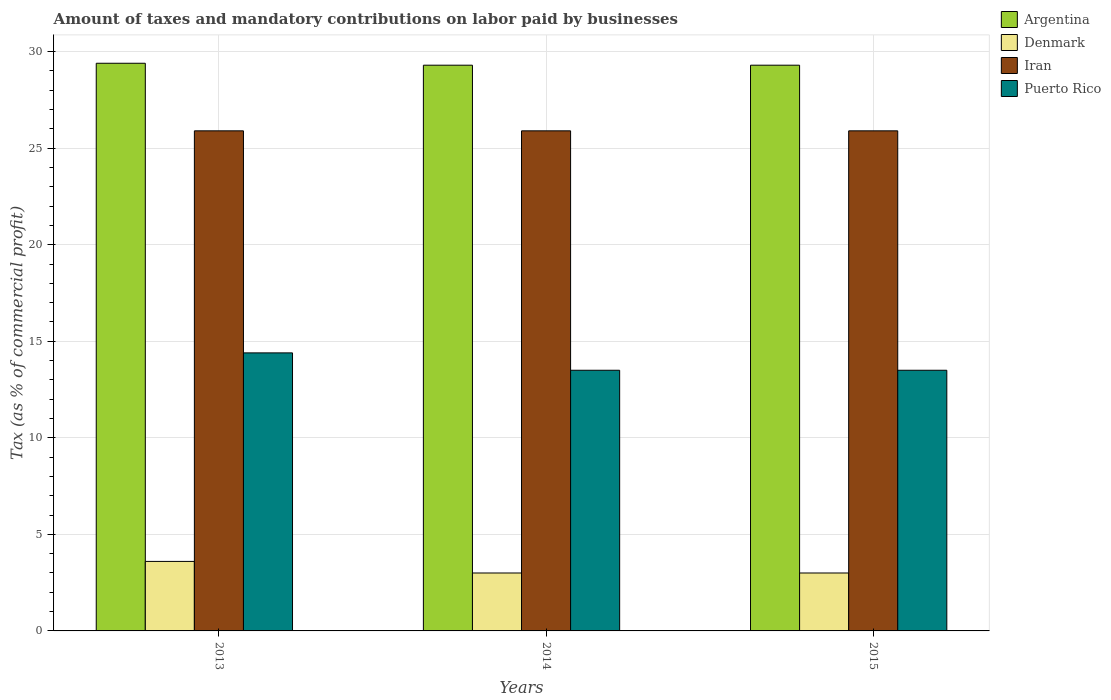How many bars are there on the 3rd tick from the left?
Keep it short and to the point. 4. How many bars are there on the 1st tick from the right?
Give a very brief answer. 4. What is the label of the 3rd group of bars from the left?
Offer a terse response. 2015. In how many cases, is the number of bars for a given year not equal to the number of legend labels?
Provide a short and direct response. 0. Across all years, what is the maximum percentage of taxes paid by businesses in Argentina?
Your answer should be very brief. 29.4. In which year was the percentage of taxes paid by businesses in Argentina maximum?
Your answer should be compact. 2013. In which year was the percentage of taxes paid by businesses in Puerto Rico minimum?
Your response must be concise. 2014. What is the total percentage of taxes paid by businesses in Argentina in the graph?
Provide a succinct answer. 88. What is the difference between the percentage of taxes paid by businesses in Iran in 2014 and that in 2015?
Your answer should be compact. 0. What is the difference between the percentage of taxes paid by businesses in Argentina in 2015 and the percentage of taxes paid by businesses in Puerto Rico in 2014?
Keep it short and to the point. 15.8. What is the average percentage of taxes paid by businesses in Puerto Rico per year?
Your answer should be compact. 13.8. In the year 2013, what is the difference between the percentage of taxes paid by businesses in Puerto Rico and percentage of taxes paid by businesses in Argentina?
Your response must be concise. -15. In how many years, is the percentage of taxes paid by businesses in Puerto Rico greater than 5 %?
Offer a very short reply. 3. Is the percentage of taxes paid by businesses in Puerto Rico in 2013 less than that in 2014?
Offer a terse response. No. Is the difference between the percentage of taxes paid by businesses in Puerto Rico in 2014 and 2015 greater than the difference between the percentage of taxes paid by businesses in Argentina in 2014 and 2015?
Provide a short and direct response. No. What is the difference between the highest and the second highest percentage of taxes paid by businesses in Denmark?
Ensure brevity in your answer.  0.6. What is the difference between the highest and the lowest percentage of taxes paid by businesses in Denmark?
Ensure brevity in your answer.  0.6. In how many years, is the percentage of taxes paid by businesses in Argentina greater than the average percentage of taxes paid by businesses in Argentina taken over all years?
Ensure brevity in your answer.  1. Is the sum of the percentage of taxes paid by businesses in Puerto Rico in 2013 and 2015 greater than the maximum percentage of taxes paid by businesses in Denmark across all years?
Your response must be concise. Yes. What does the 4th bar from the left in 2013 represents?
Make the answer very short. Puerto Rico. Is it the case that in every year, the sum of the percentage of taxes paid by businesses in Argentina and percentage of taxes paid by businesses in Puerto Rico is greater than the percentage of taxes paid by businesses in Denmark?
Keep it short and to the point. Yes. Does the graph contain any zero values?
Offer a terse response. No. Where does the legend appear in the graph?
Your response must be concise. Top right. How are the legend labels stacked?
Your answer should be compact. Vertical. What is the title of the graph?
Provide a succinct answer. Amount of taxes and mandatory contributions on labor paid by businesses. Does "Cameroon" appear as one of the legend labels in the graph?
Your answer should be compact. No. What is the label or title of the X-axis?
Offer a very short reply. Years. What is the label or title of the Y-axis?
Your answer should be compact. Tax (as % of commercial profit). What is the Tax (as % of commercial profit) in Argentina in 2013?
Offer a very short reply. 29.4. What is the Tax (as % of commercial profit) of Iran in 2013?
Offer a very short reply. 25.9. What is the Tax (as % of commercial profit) in Puerto Rico in 2013?
Your response must be concise. 14.4. What is the Tax (as % of commercial profit) in Argentina in 2014?
Your answer should be very brief. 29.3. What is the Tax (as % of commercial profit) in Denmark in 2014?
Offer a terse response. 3. What is the Tax (as % of commercial profit) of Iran in 2014?
Your response must be concise. 25.9. What is the Tax (as % of commercial profit) of Argentina in 2015?
Offer a very short reply. 29.3. What is the Tax (as % of commercial profit) in Denmark in 2015?
Make the answer very short. 3. What is the Tax (as % of commercial profit) in Iran in 2015?
Give a very brief answer. 25.9. What is the Tax (as % of commercial profit) of Puerto Rico in 2015?
Offer a very short reply. 13.5. Across all years, what is the maximum Tax (as % of commercial profit) of Argentina?
Ensure brevity in your answer.  29.4. Across all years, what is the maximum Tax (as % of commercial profit) of Denmark?
Your response must be concise. 3.6. Across all years, what is the maximum Tax (as % of commercial profit) of Iran?
Your answer should be compact. 25.9. Across all years, what is the maximum Tax (as % of commercial profit) in Puerto Rico?
Keep it short and to the point. 14.4. Across all years, what is the minimum Tax (as % of commercial profit) of Argentina?
Ensure brevity in your answer.  29.3. Across all years, what is the minimum Tax (as % of commercial profit) in Iran?
Ensure brevity in your answer.  25.9. Across all years, what is the minimum Tax (as % of commercial profit) of Puerto Rico?
Your answer should be very brief. 13.5. What is the total Tax (as % of commercial profit) of Argentina in the graph?
Your response must be concise. 88. What is the total Tax (as % of commercial profit) of Iran in the graph?
Keep it short and to the point. 77.7. What is the total Tax (as % of commercial profit) of Puerto Rico in the graph?
Your response must be concise. 41.4. What is the difference between the Tax (as % of commercial profit) in Argentina in 2013 and that in 2014?
Your response must be concise. 0.1. What is the difference between the Tax (as % of commercial profit) of Puerto Rico in 2013 and that in 2014?
Ensure brevity in your answer.  0.9. What is the difference between the Tax (as % of commercial profit) of Denmark in 2013 and that in 2015?
Offer a very short reply. 0.6. What is the difference between the Tax (as % of commercial profit) of Puerto Rico in 2014 and that in 2015?
Your response must be concise. 0. What is the difference between the Tax (as % of commercial profit) in Argentina in 2013 and the Tax (as % of commercial profit) in Denmark in 2014?
Provide a short and direct response. 26.4. What is the difference between the Tax (as % of commercial profit) in Denmark in 2013 and the Tax (as % of commercial profit) in Iran in 2014?
Make the answer very short. -22.3. What is the difference between the Tax (as % of commercial profit) of Denmark in 2013 and the Tax (as % of commercial profit) of Puerto Rico in 2014?
Offer a terse response. -9.9. What is the difference between the Tax (as % of commercial profit) of Argentina in 2013 and the Tax (as % of commercial profit) of Denmark in 2015?
Make the answer very short. 26.4. What is the difference between the Tax (as % of commercial profit) of Argentina in 2013 and the Tax (as % of commercial profit) of Iran in 2015?
Your answer should be compact. 3.5. What is the difference between the Tax (as % of commercial profit) of Argentina in 2013 and the Tax (as % of commercial profit) of Puerto Rico in 2015?
Your answer should be very brief. 15.9. What is the difference between the Tax (as % of commercial profit) of Denmark in 2013 and the Tax (as % of commercial profit) of Iran in 2015?
Provide a short and direct response. -22.3. What is the difference between the Tax (as % of commercial profit) of Iran in 2013 and the Tax (as % of commercial profit) of Puerto Rico in 2015?
Provide a succinct answer. 12.4. What is the difference between the Tax (as % of commercial profit) in Argentina in 2014 and the Tax (as % of commercial profit) in Denmark in 2015?
Your answer should be compact. 26.3. What is the difference between the Tax (as % of commercial profit) of Argentina in 2014 and the Tax (as % of commercial profit) of Puerto Rico in 2015?
Provide a succinct answer. 15.8. What is the difference between the Tax (as % of commercial profit) of Denmark in 2014 and the Tax (as % of commercial profit) of Iran in 2015?
Provide a succinct answer. -22.9. What is the average Tax (as % of commercial profit) in Argentina per year?
Make the answer very short. 29.33. What is the average Tax (as % of commercial profit) of Iran per year?
Offer a very short reply. 25.9. What is the average Tax (as % of commercial profit) of Puerto Rico per year?
Provide a succinct answer. 13.8. In the year 2013, what is the difference between the Tax (as % of commercial profit) in Argentina and Tax (as % of commercial profit) in Denmark?
Your answer should be compact. 25.8. In the year 2013, what is the difference between the Tax (as % of commercial profit) in Denmark and Tax (as % of commercial profit) in Iran?
Give a very brief answer. -22.3. In the year 2014, what is the difference between the Tax (as % of commercial profit) in Argentina and Tax (as % of commercial profit) in Denmark?
Provide a short and direct response. 26.3. In the year 2014, what is the difference between the Tax (as % of commercial profit) in Denmark and Tax (as % of commercial profit) in Iran?
Provide a succinct answer. -22.9. In the year 2015, what is the difference between the Tax (as % of commercial profit) of Argentina and Tax (as % of commercial profit) of Denmark?
Your answer should be very brief. 26.3. In the year 2015, what is the difference between the Tax (as % of commercial profit) of Argentina and Tax (as % of commercial profit) of Iran?
Keep it short and to the point. 3.4. In the year 2015, what is the difference between the Tax (as % of commercial profit) in Denmark and Tax (as % of commercial profit) in Iran?
Your answer should be very brief. -22.9. In the year 2015, what is the difference between the Tax (as % of commercial profit) of Denmark and Tax (as % of commercial profit) of Puerto Rico?
Provide a succinct answer. -10.5. In the year 2015, what is the difference between the Tax (as % of commercial profit) of Iran and Tax (as % of commercial profit) of Puerto Rico?
Offer a terse response. 12.4. What is the ratio of the Tax (as % of commercial profit) of Argentina in 2013 to that in 2014?
Offer a terse response. 1. What is the ratio of the Tax (as % of commercial profit) in Denmark in 2013 to that in 2014?
Provide a succinct answer. 1.2. What is the ratio of the Tax (as % of commercial profit) in Puerto Rico in 2013 to that in 2014?
Give a very brief answer. 1.07. What is the ratio of the Tax (as % of commercial profit) of Argentina in 2013 to that in 2015?
Your response must be concise. 1. What is the ratio of the Tax (as % of commercial profit) of Denmark in 2013 to that in 2015?
Make the answer very short. 1.2. What is the ratio of the Tax (as % of commercial profit) of Puerto Rico in 2013 to that in 2015?
Your answer should be compact. 1.07. What is the ratio of the Tax (as % of commercial profit) in Argentina in 2014 to that in 2015?
Offer a very short reply. 1. What is the difference between the highest and the second highest Tax (as % of commercial profit) of Iran?
Your answer should be very brief. 0. What is the difference between the highest and the lowest Tax (as % of commercial profit) of Argentina?
Ensure brevity in your answer.  0.1. 